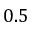<formula> <loc_0><loc_0><loc_500><loc_500>0 . 5</formula> 